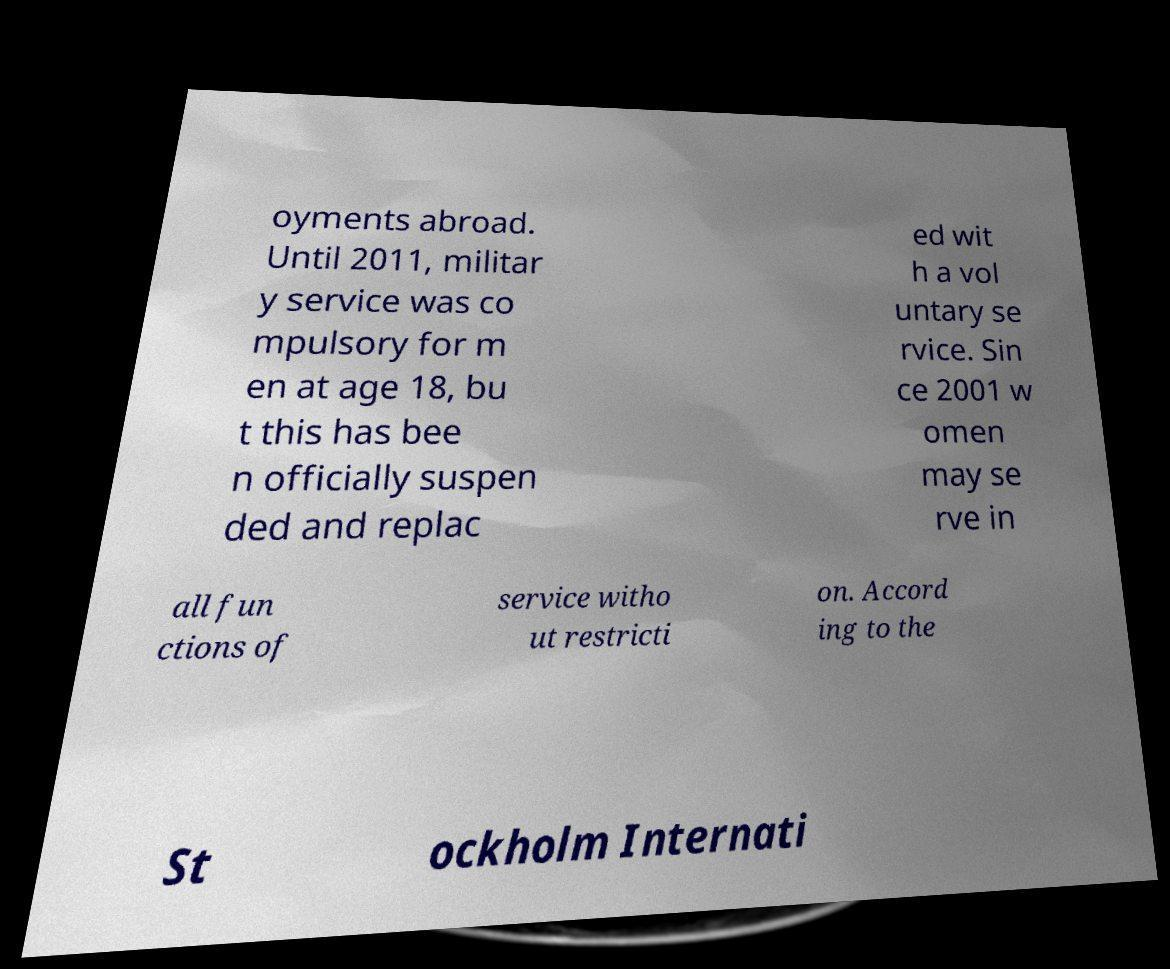For documentation purposes, I need the text within this image transcribed. Could you provide that? oyments abroad. Until 2011, militar y service was co mpulsory for m en at age 18, bu t this has bee n officially suspen ded and replac ed wit h a vol untary se rvice. Sin ce 2001 w omen may se rve in all fun ctions of service witho ut restricti on. Accord ing to the St ockholm Internati 